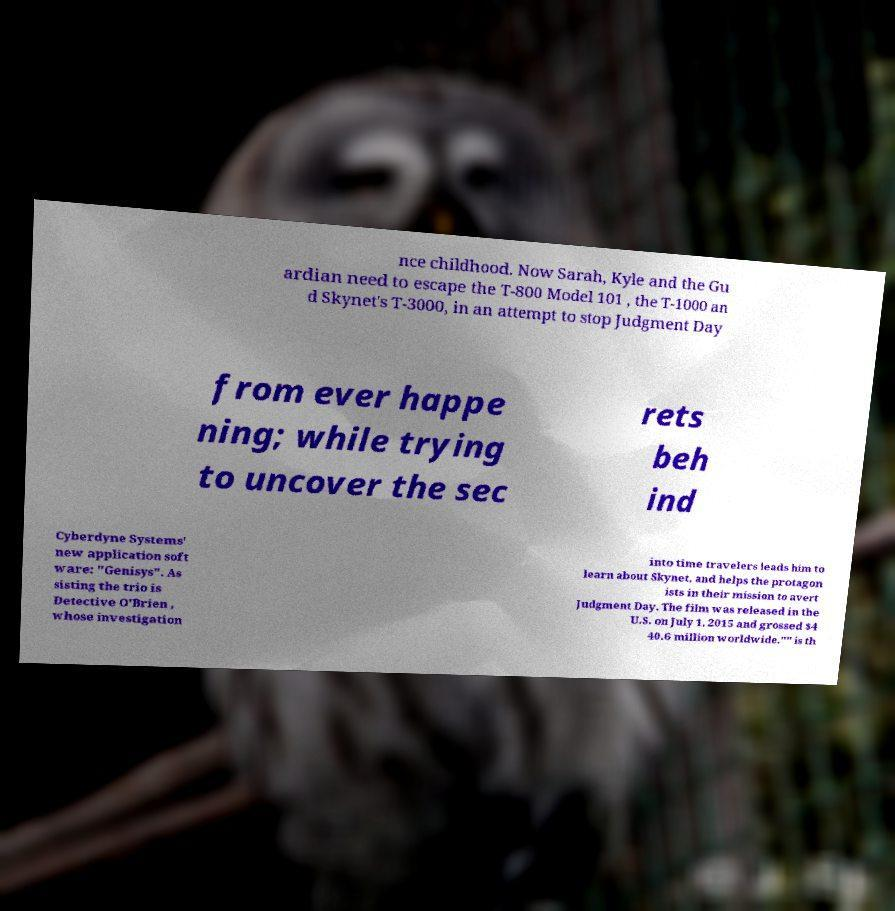There's text embedded in this image that I need extracted. Can you transcribe it verbatim? nce childhood. Now Sarah, Kyle and the Gu ardian need to escape the T-800 Model 101 , the T-1000 an d Skynet's T-3000, in an attempt to stop Judgment Day from ever happe ning; while trying to uncover the sec rets beh ind Cyberdyne Systems' new application soft ware: "Genisys". As sisting the trio is Detective O'Brien , whose investigation into time travelers leads him to learn about Skynet, and helps the protagon ists in their mission to avert Judgment Day. The film was released in the U.S. on July 1, 2015 and grossed $4 40.6 million worldwide."" is th 